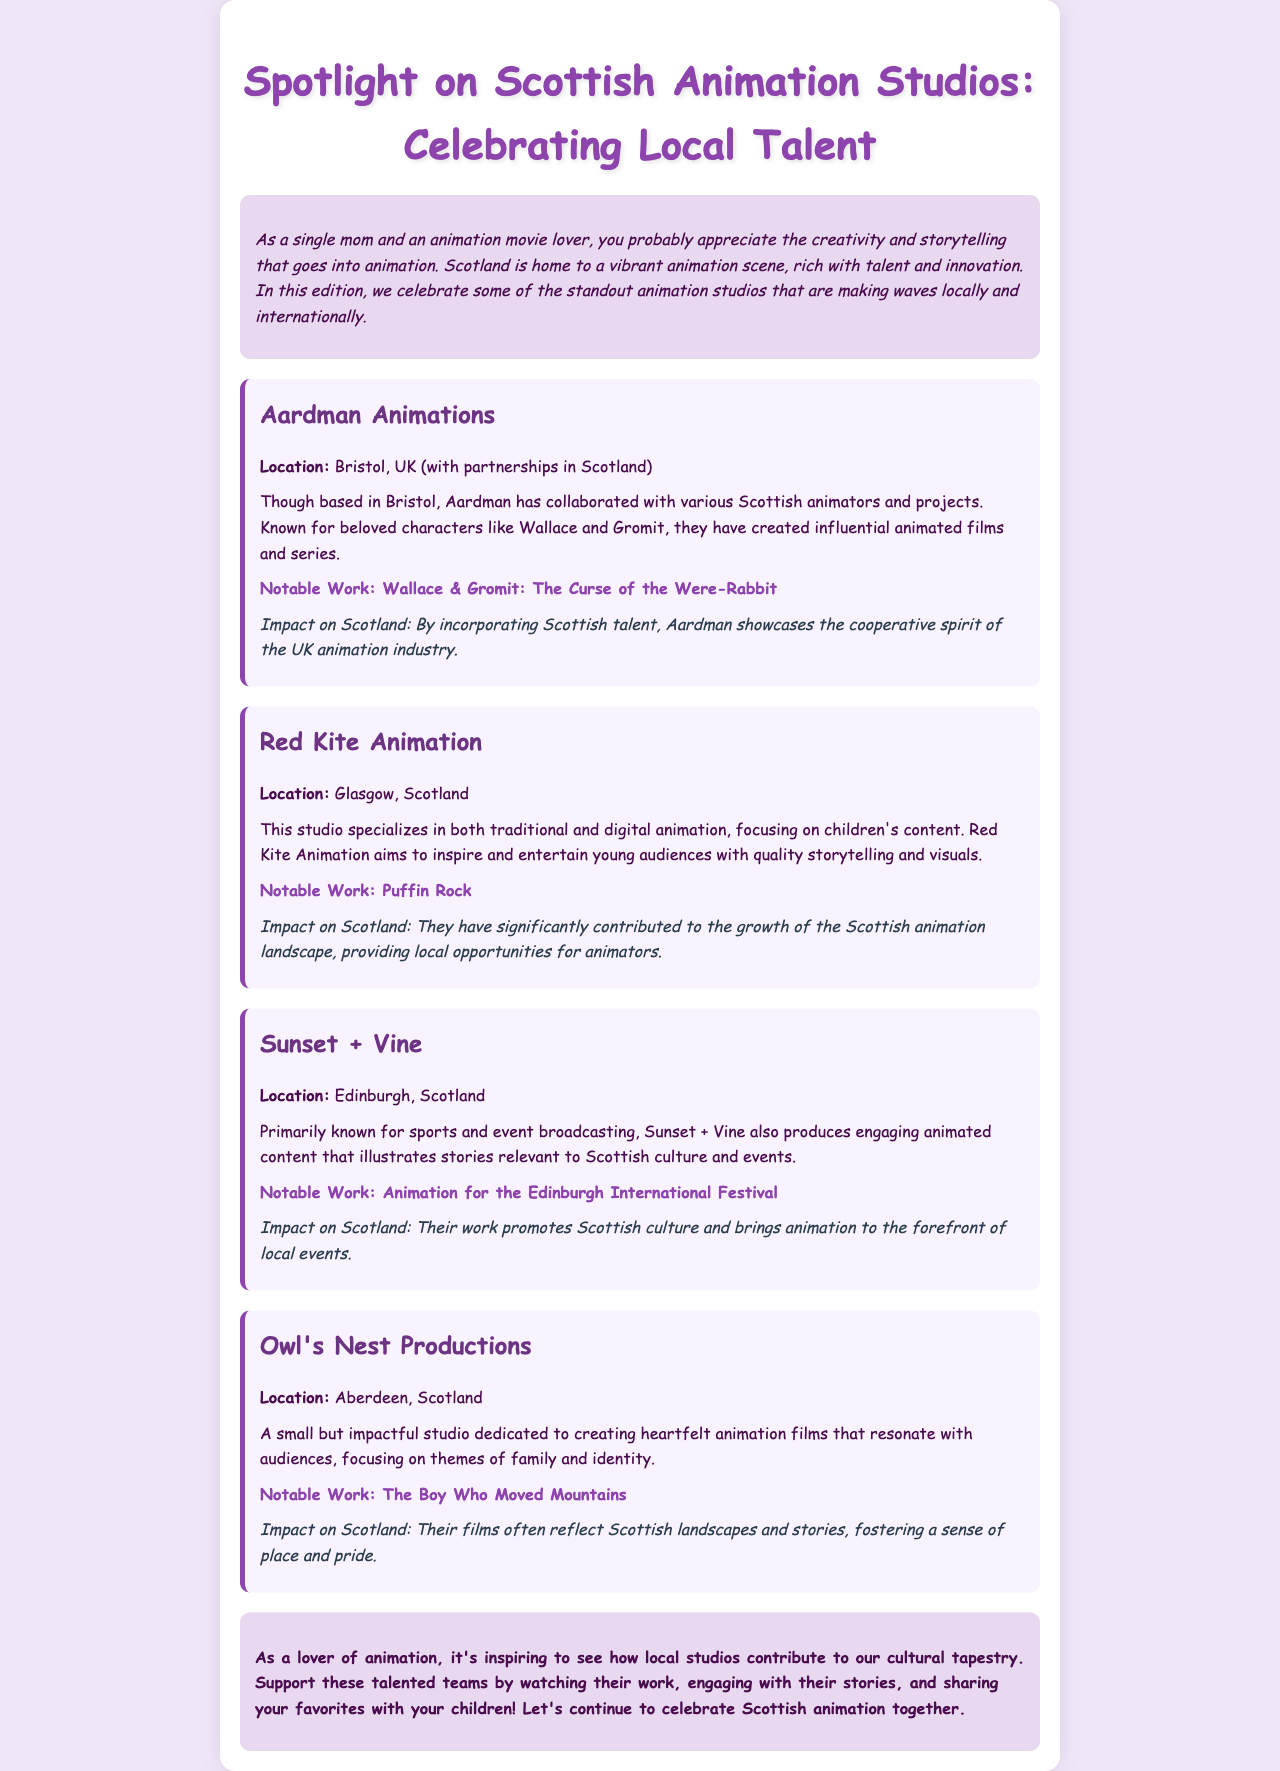What is the focus of Red Kite Animation? Red Kite Animation specializes in children's content, aiming to inspire and entertain young audiences with quality storytelling and visuals.
Answer: Children's content Where is Owl's Nest Productions located? The location of Owl's Nest Productions is mentioned in the document.
Answer: Aberdeen, Scotland What significant impact has Red Kite Animation had in Scotland? Red Kite Animation has contributed to the growth of the Scottish animation landscape by providing local opportunities for animators.
Answer: Local opportunities for animators What notable work is associated with Aardman Animations? The document lists a notable work from Aardman Animations, which is a well-known project.
Answer: Wallace & Gromit: The Curse of the Were-Rabbit Which studio is primarily known for sports and event broadcasting? The document highlights the specialization of a studio in broadcasting, alongside animation.
Answer: Sunset + Vine What does the closing section of the document encourage readers to do? The closing thoughts emphasize a specific action for readers related to local animation studios in Scotland.
Answer: Support these talented teams What animation project did Sunset + Vine create for the Edinburgh International Festival? The document provides a specific work that showcases the studio's contribution to local events.
Answer: Animation for the Edinburgh International Festival What themes does Owl's Nest Productions focus on in their films? The document specifies the main themes that Owl's Nest Productions addresses in their animation films.
Answer: Family and identity 